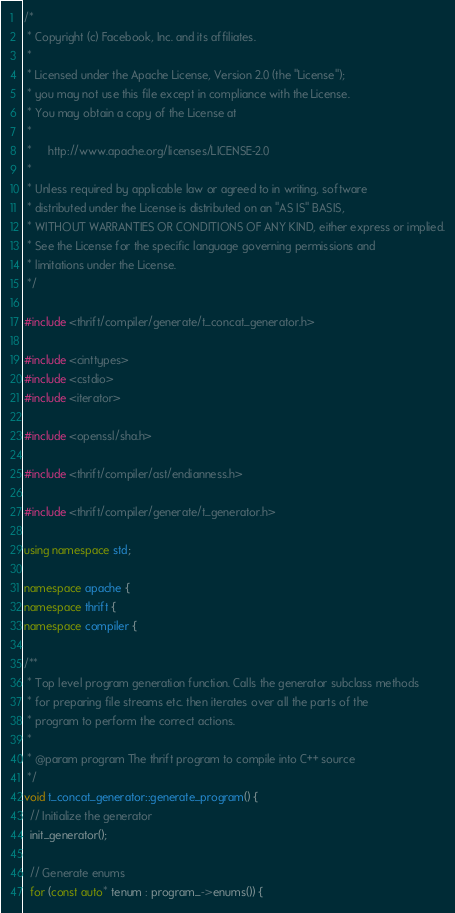Convert code to text. <code><loc_0><loc_0><loc_500><loc_500><_C++_>/*
 * Copyright (c) Facebook, Inc. and its affiliates.
 *
 * Licensed under the Apache License, Version 2.0 (the "License");
 * you may not use this file except in compliance with the License.
 * You may obtain a copy of the License at
 *
 *     http://www.apache.org/licenses/LICENSE-2.0
 *
 * Unless required by applicable law or agreed to in writing, software
 * distributed under the License is distributed on an "AS IS" BASIS,
 * WITHOUT WARRANTIES OR CONDITIONS OF ANY KIND, either express or implied.
 * See the License for the specific language governing permissions and
 * limitations under the License.
 */

#include <thrift/compiler/generate/t_concat_generator.h>

#include <cinttypes>
#include <cstdio>
#include <iterator>

#include <openssl/sha.h>

#include <thrift/compiler/ast/endianness.h>

#include <thrift/compiler/generate/t_generator.h>

using namespace std;

namespace apache {
namespace thrift {
namespace compiler {

/**
 * Top level program generation function. Calls the generator subclass methods
 * for preparing file streams etc. then iterates over all the parts of the
 * program to perform the correct actions.
 *
 * @param program The thrift program to compile into C++ source
 */
void t_concat_generator::generate_program() {
  // Initialize the generator
  init_generator();

  // Generate enums
  for (const auto* tenum : program_->enums()) {</code> 